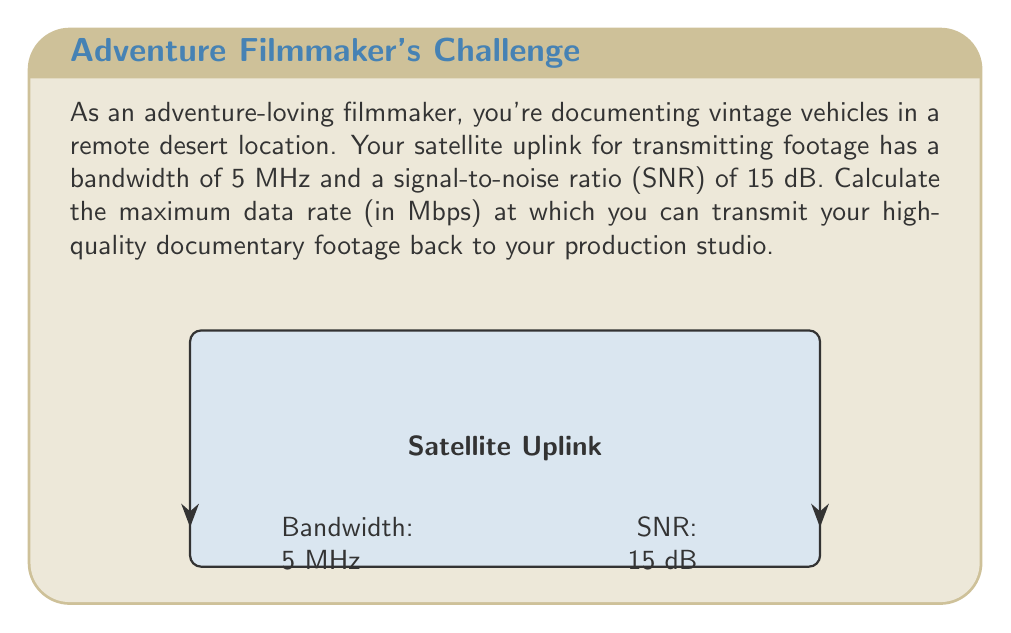What is the answer to this math problem? To solve this problem, we'll use the Shannon-Hartley theorem, which gives the channel capacity for a communication channel with Gaussian noise.

The Shannon-Hartley theorem states:

$$ C = B \log_2(1 + SNR) $$

Where:
- $C$ is the channel capacity in bits per second (bps)
- $B$ is the bandwidth in Hz
- $SNR$ is the linear signal-to-noise ratio

Steps to solve:

1) We're given the bandwidth $B = 5$ MHz = $5 \times 10^6$ Hz

2) The SNR is given in dB, so we need to convert it to a linear ratio:
   $SNR_{linear} = 10^{(SNR_{dB}/10)} = 10^{(15/10)} = 10^{1.5} \approx 31.6228$

3) Now we can plug these values into the Shannon-Hartley theorem:

   $$ C = (5 \times 10^6) \log_2(1 + 31.6228) $$

4) Calculate:
   $$ C = (5 \times 10^6) \log_2(32.6228) $$
   $$ C = (5 \times 10^6) (5.0279) $$
   $$ C = 25,139,500 \text{ bps} $$

5) Convert to Mbps:
   $$ C = 25.1395 \text{ Mbps} $$

Therefore, the maximum data rate at which you can transmit your footage is approximately 25.14 Mbps.
Answer: 25.14 Mbps 